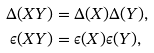<formula> <loc_0><loc_0><loc_500><loc_500>\Delta ( X Y ) & = \Delta ( X ) \Delta ( Y ) , \\ \epsilon ( X Y ) & = \epsilon ( X ) \epsilon ( Y ) , \\</formula> 